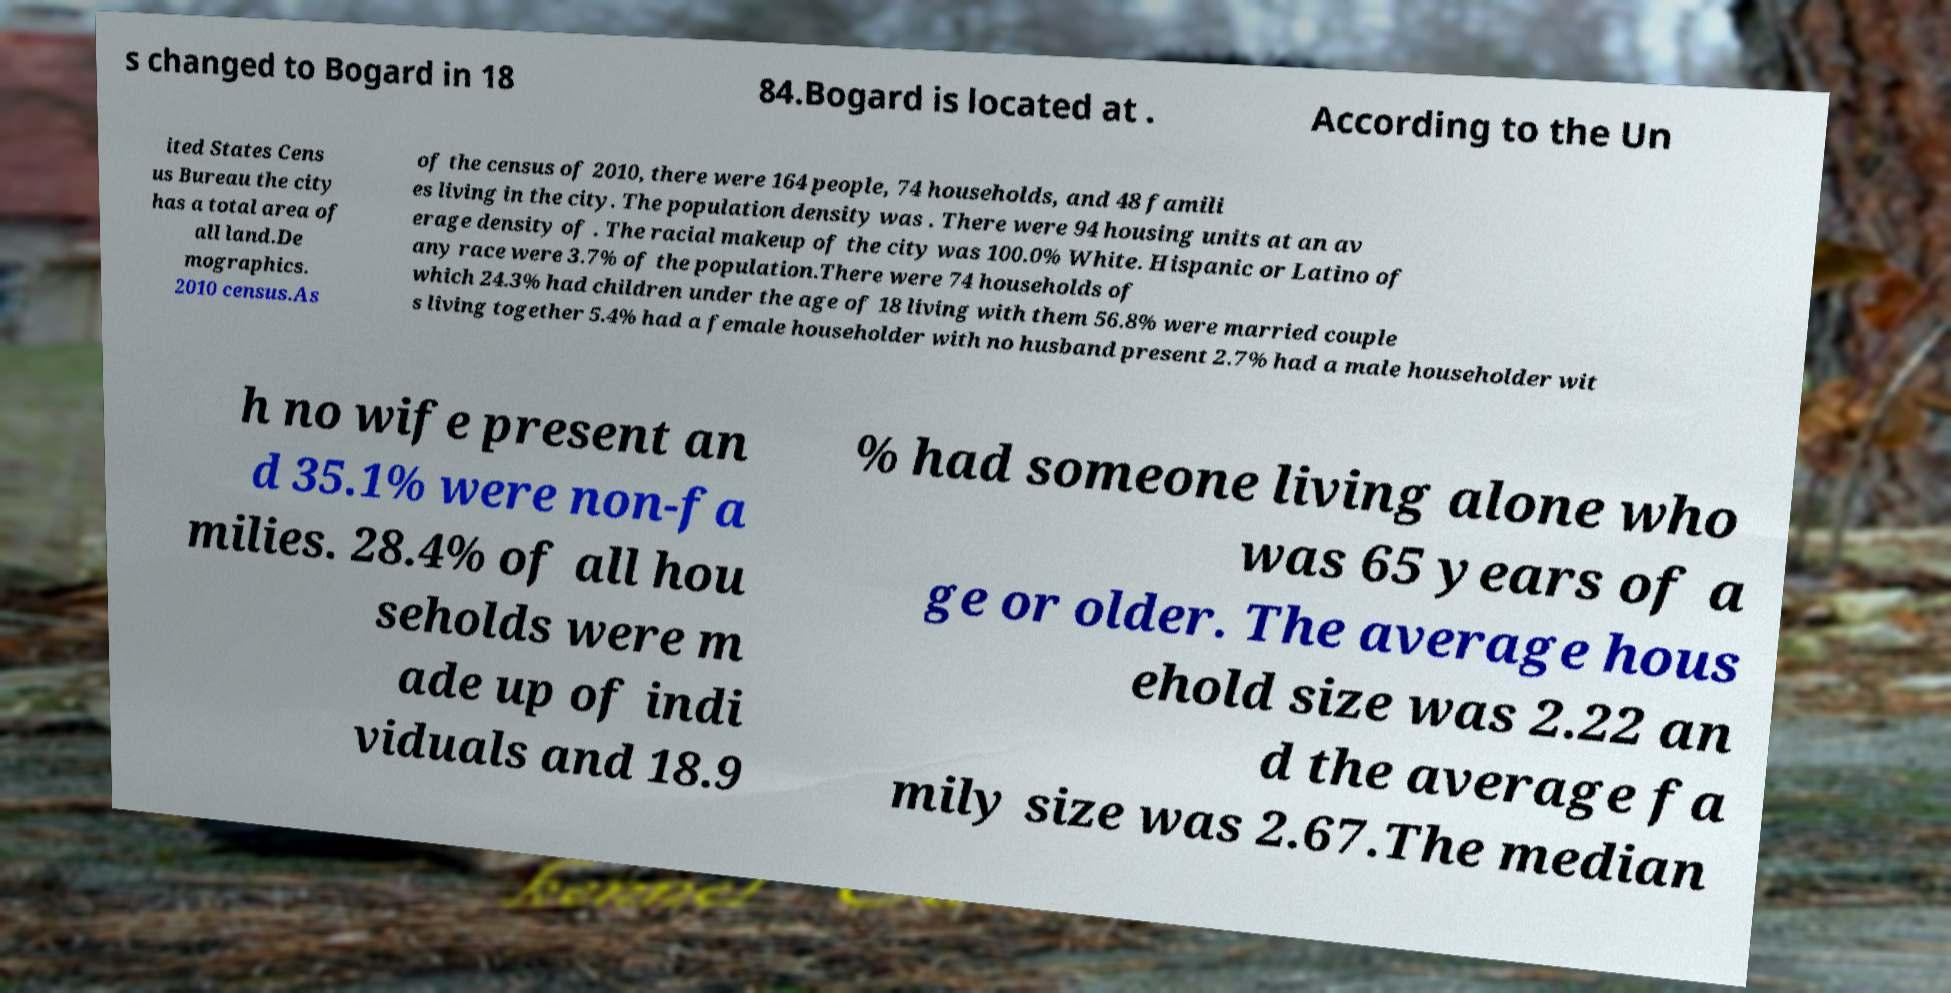Can you accurately transcribe the text from the provided image for me? s changed to Bogard in 18 84.Bogard is located at . According to the Un ited States Cens us Bureau the city has a total area of all land.De mographics. 2010 census.As of the census of 2010, there were 164 people, 74 households, and 48 famili es living in the city. The population density was . There were 94 housing units at an av erage density of . The racial makeup of the city was 100.0% White. Hispanic or Latino of any race were 3.7% of the population.There were 74 households of which 24.3% had children under the age of 18 living with them 56.8% were married couple s living together 5.4% had a female householder with no husband present 2.7% had a male householder wit h no wife present an d 35.1% were non-fa milies. 28.4% of all hou seholds were m ade up of indi viduals and 18.9 % had someone living alone who was 65 years of a ge or older. The average hous ehold size was 2.22 an d the average fa mily size was 2.67.The median 